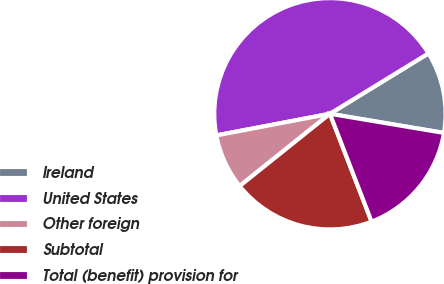Convert chart to OTSL. <chart><loc_0><loc_0><loc_500><loc_500><pie_chart><fcel>Ireland<fcel>United States<fcel>Other foreign<fcel>Subtotal<fcel>Total (benefit) provision for<nl><fcel>11.4%<fcel>44.24%<fcel>7.75%<fcel>20.12%<fcel>16.48%<nl></chart> 